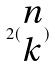Convert formula to latex. <formula><loc_0><loc_0><loc_500><loc_500>2 ( \begin{matrix} n \\ k \end{matrix} )</formula> 